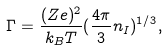Convert formula to latex. <formula><loc_0><loc_0><loc_500><loc_500>\Gamma = \frac { ( Z e ) ^ { 2 } } { k _ { B } T } ( \frac { 4 \pi } { 3 } n _ { I } ) ^ { 1 / 3 } ,</formula> 